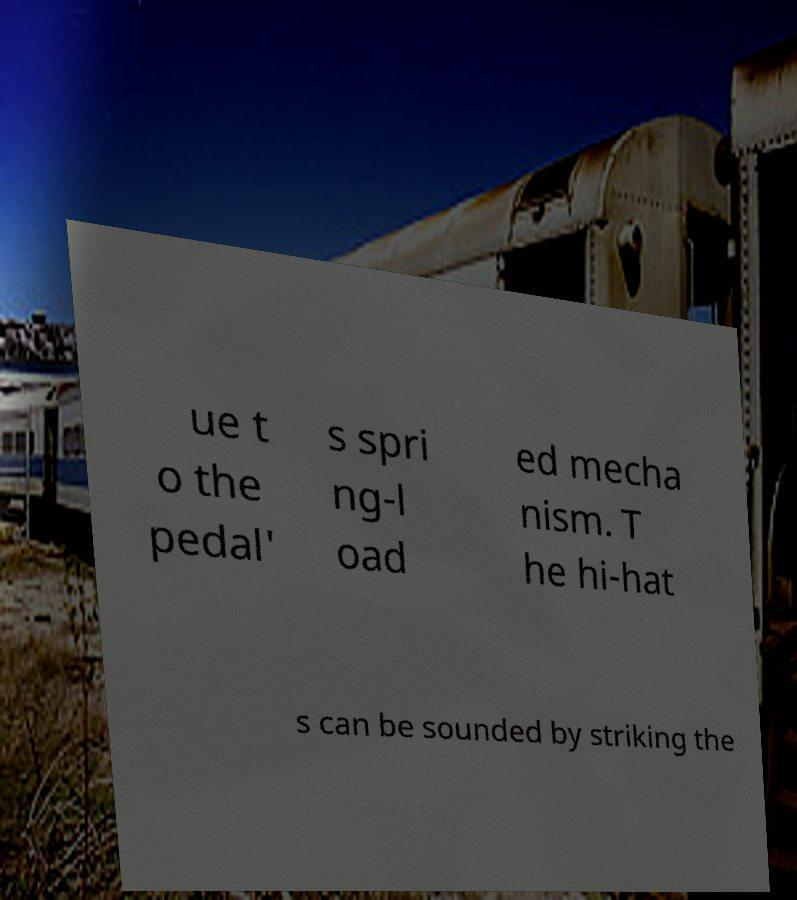I need the written content from this picture converted into text. Can you do that? ue t o the pedal' s spri ng-l oad ed mecha nism. T he hi-hat s can be sounded by striking the 